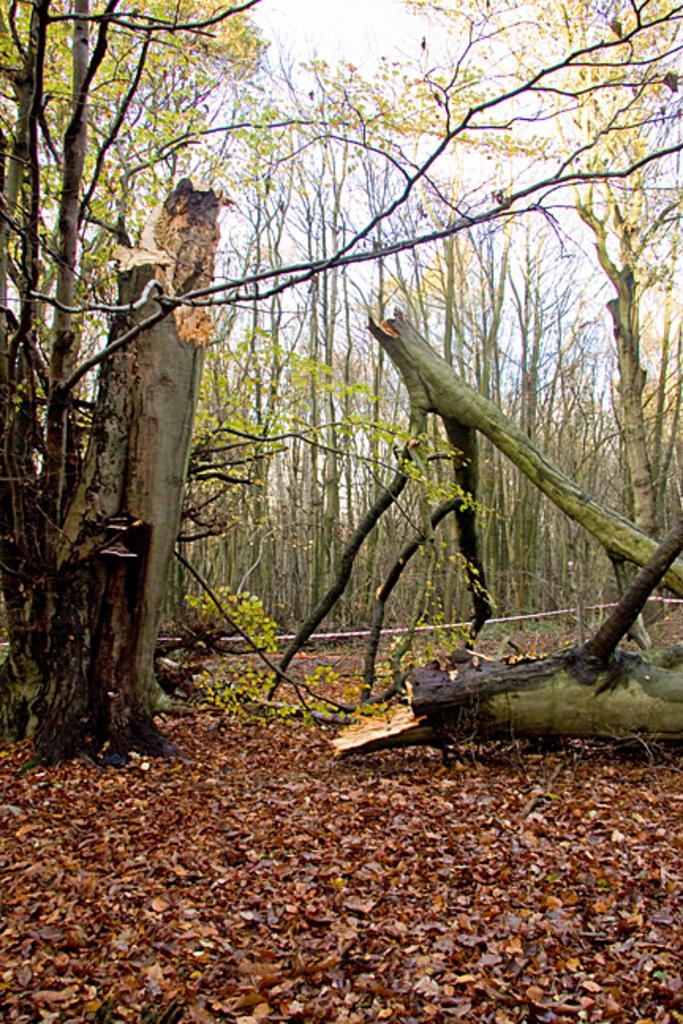Describe this image in one or two sentences. In this image, there are a few trees. We can see the ground with some dried leaves. We can also see a rope and some plants. We can see the sky. 